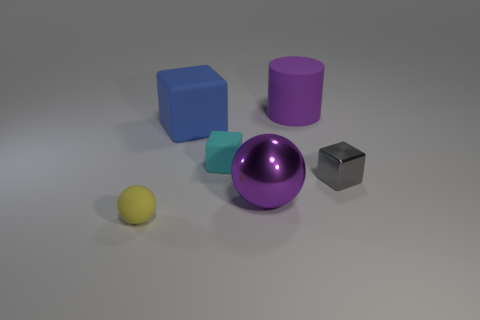Add 3 matte balls. How many objects exist? 9 Subtract all spheres. How many objects are left? 4 Add 2 small rubber things. How many small rubber things exist? 4 Subtract 1 yellow spheres. How many objects are left? 5 Subtract all cyan matte blocks. Subtract all gray blocks. How many objects are left? 4 Add 3 big matte cylinders. How many big matte cylinders are left? 4 